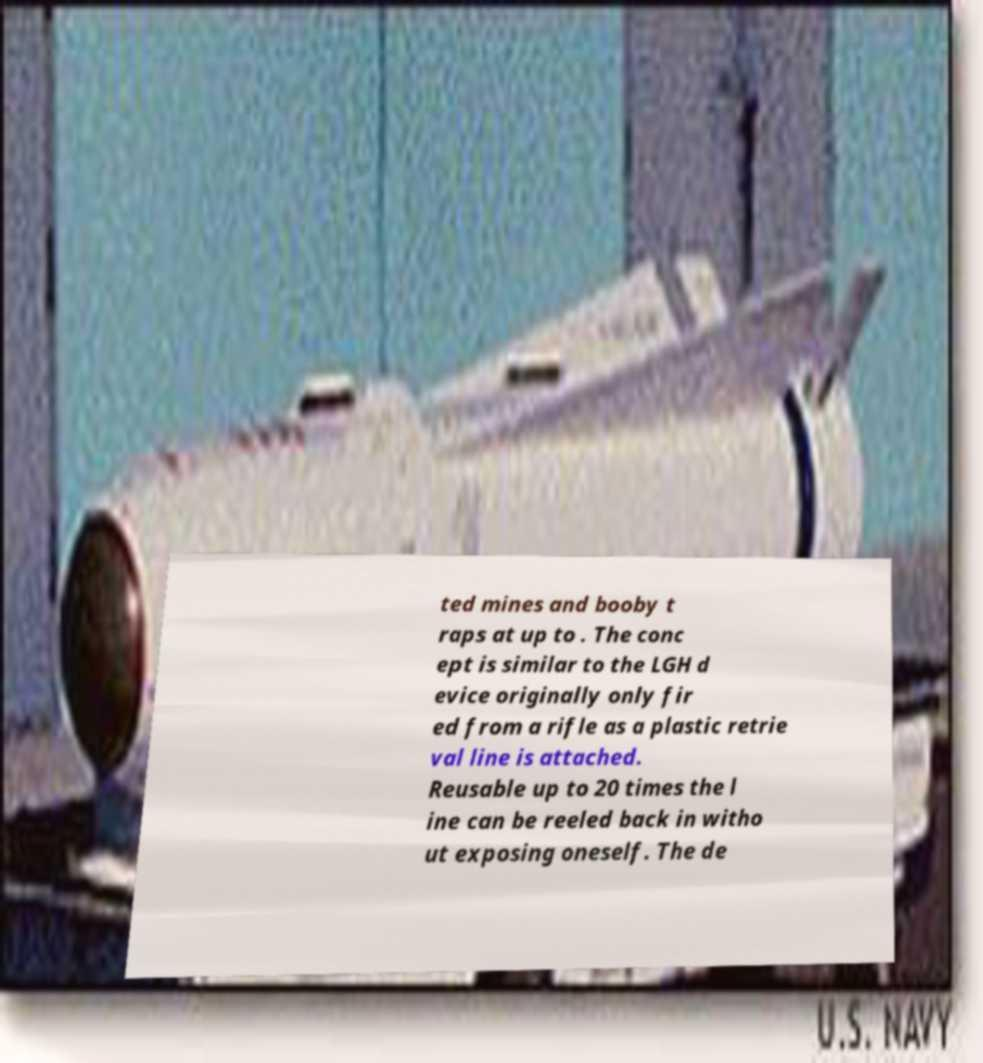What messages or text are displayed in this image? I need them in a readable, typed format. ted mines and booby t raps at up to . The conc ept is similar to the LGH d evice originally only fir ed from a rifle as a plastic retrie val line is attached. Reusable up to 20 times the l ine can be reeled back in witho ut exposing oneself. The de 